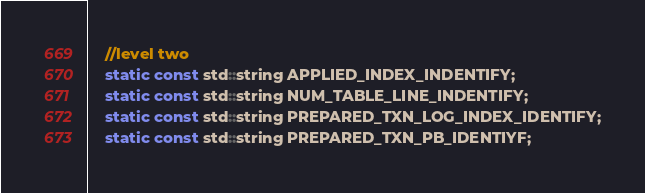<code> <loc_0><loc_0><loc_500><loc_500><_C_>    //level two
    static const std::string APPLIED_INDEX_INDENTIFY;
    static const std::string NUM_TABLE_LINE_INDENTIFY;
    static const std::string PREPARED_TXN_LOG_INDEX_IDENTIFY;
    static const std::string PREPARED_TXN_PB_IDENTIYF;</code> 